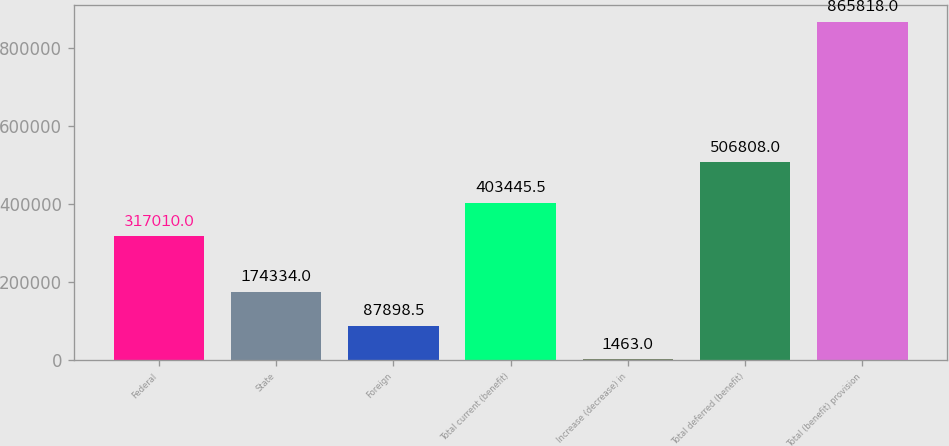Convert chart. <chart><loc_0><loc_0><loc_500><loc_500><bar_chart><fcel>Federal<fcel>State<fcel>Foreign<fcel>Total current (benefit)<fcel>Increase (decrease) in<fcel>Total deferred (benefit)<fcel>Total (benefit) provision<nl><fcel>317010<fcel>174334<fcel>87898.5<fcel>403446<fcel>1463<fcel>506808<fcel>865818<nl></chart> 